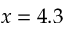Convert formula to latex. <formula><loc_0><loc_0><loc_500><loc_500>x = 4 . 3</formula> 